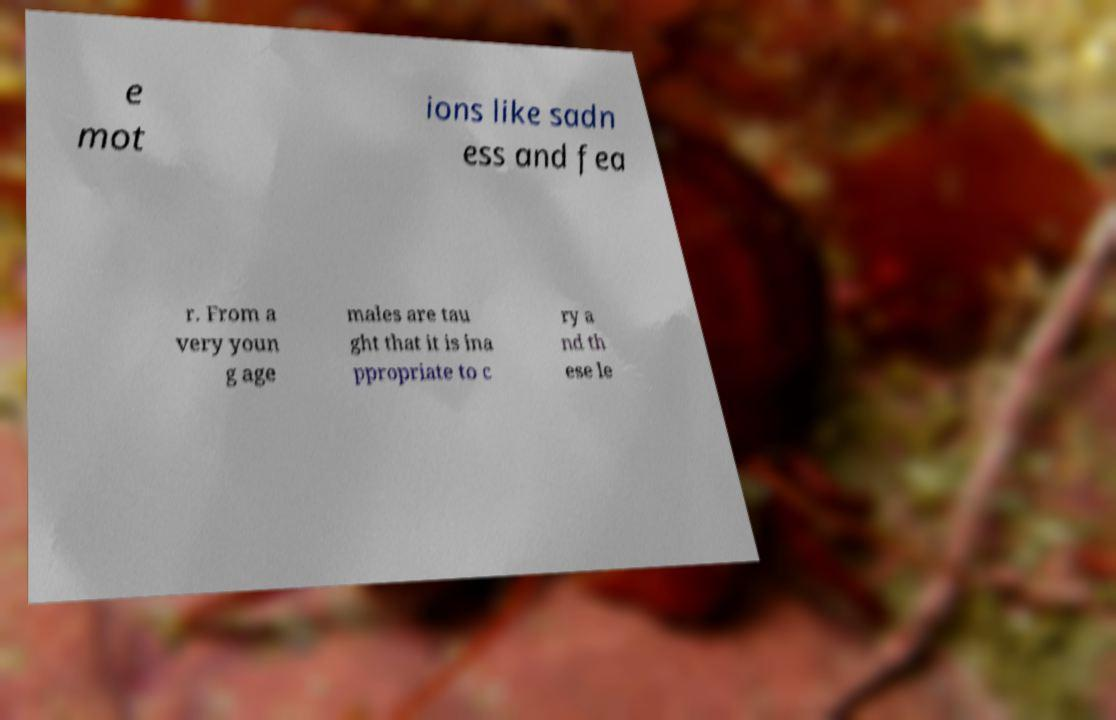Can you read and provide the text displayed in the image?This photo seems to have some interesting text. Can you extract and type it out for me? e mot ions like sadn ess and fea r. From a very youn g age males are tau ght that it is ina ppropriate to c ry a nd th ese le 